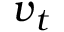<formula> <loc_0><loc_0><loc_500><loc_500>v _ { t }</formula> 